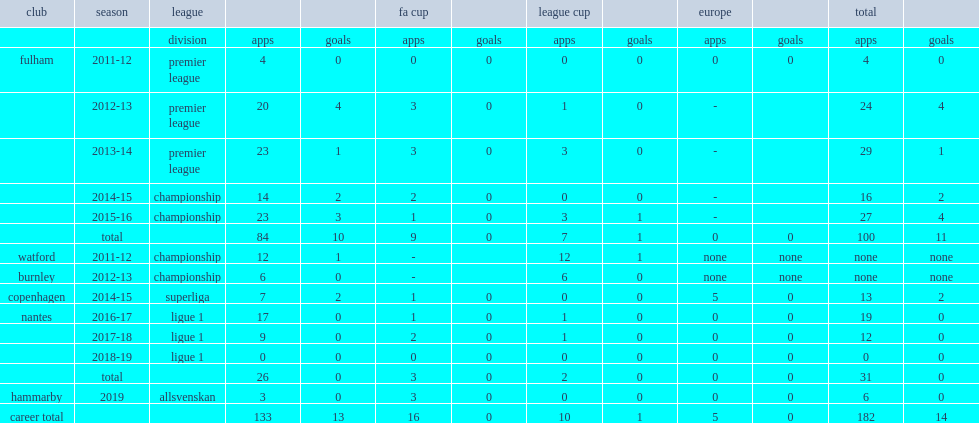In 2019, which league did kacaniklic join with hammarby in? Allsvenskan. 